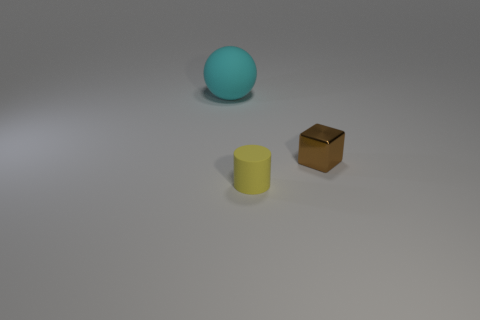Add 2 small red cylinders. How many objects exist? 5 Subtract all cylinders. How many objects are left? 2 Subtract 0 purple blocks. How many objects are left? 3 Subtract all metal things. Subtract all yellow rubber objects. How many objects are left? 1 Add 3 cyan rubber things. How many cyan rubber things are left? 4 Add 2 large purple matte objects. How many large purple matte objects exist? 2 